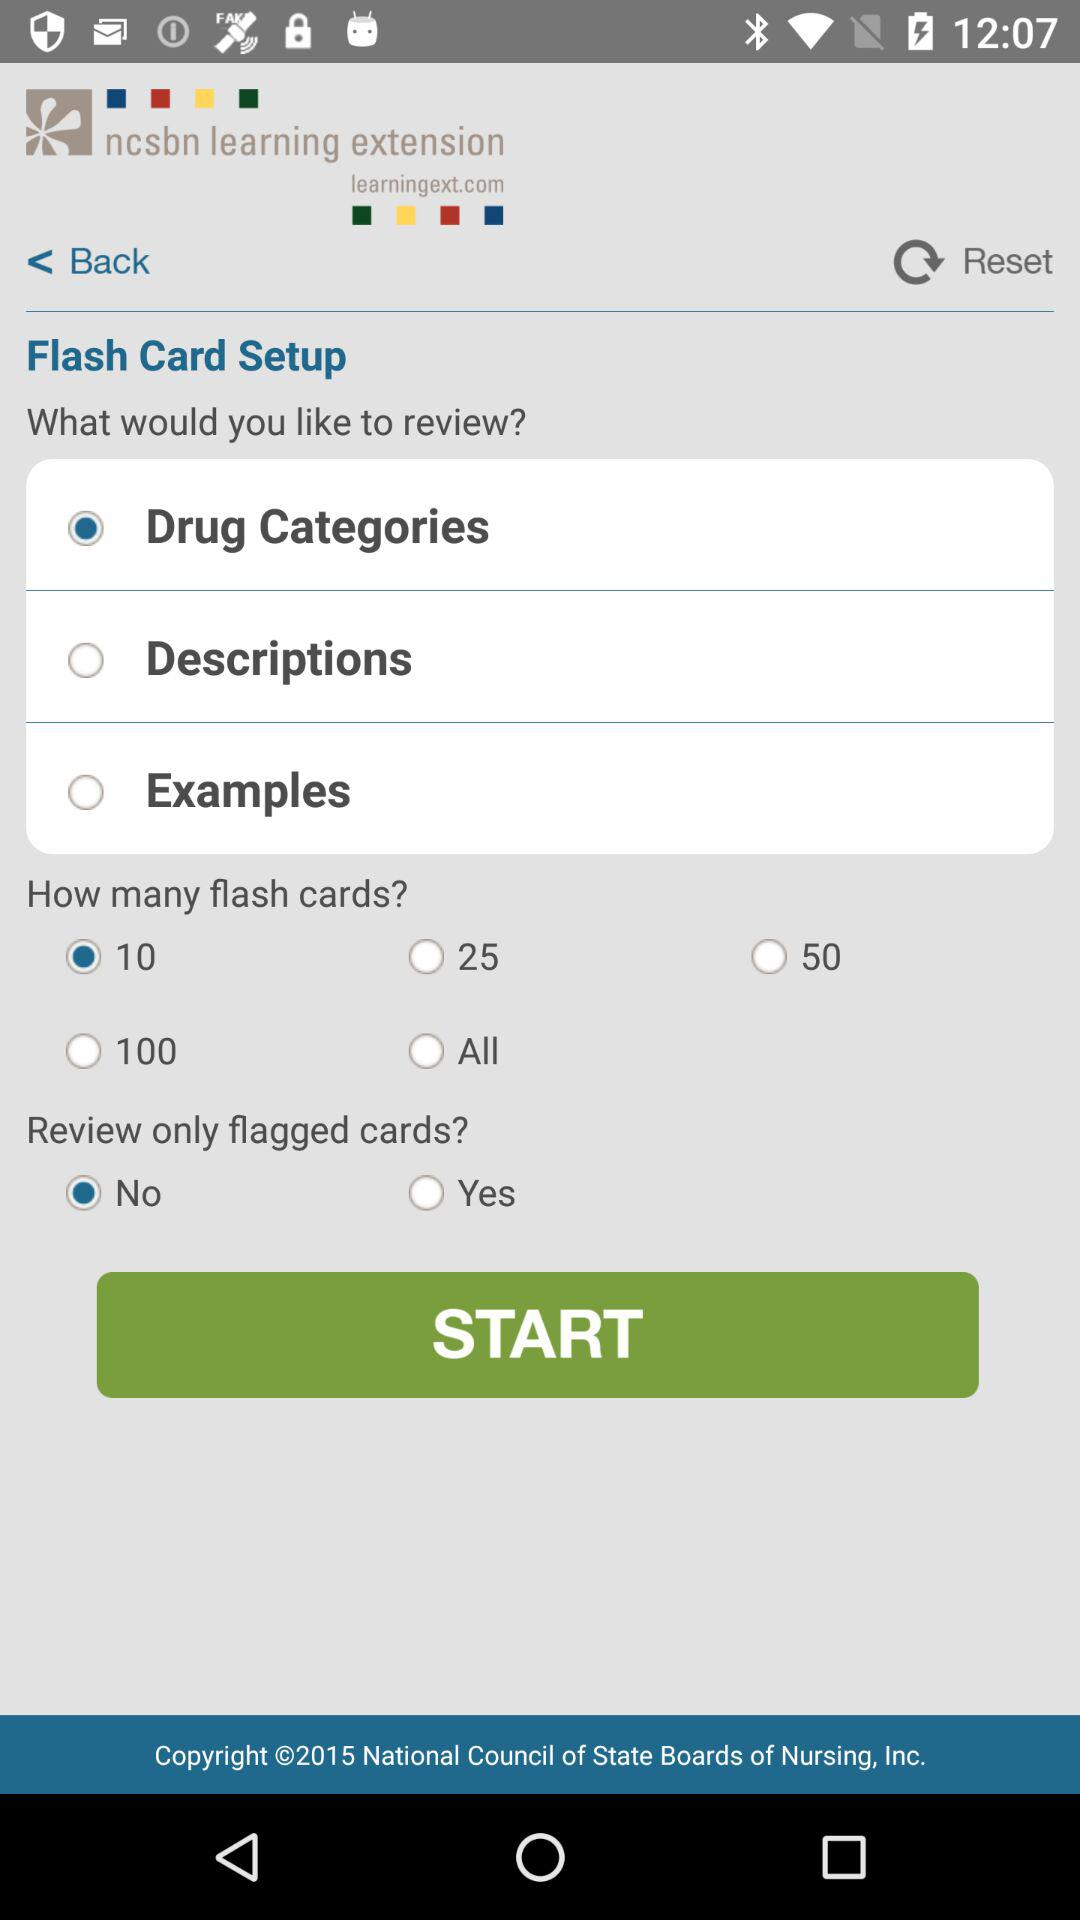What is the version of this application?
When the provided information is insufficient, respond with <no answer>. <no answer> 